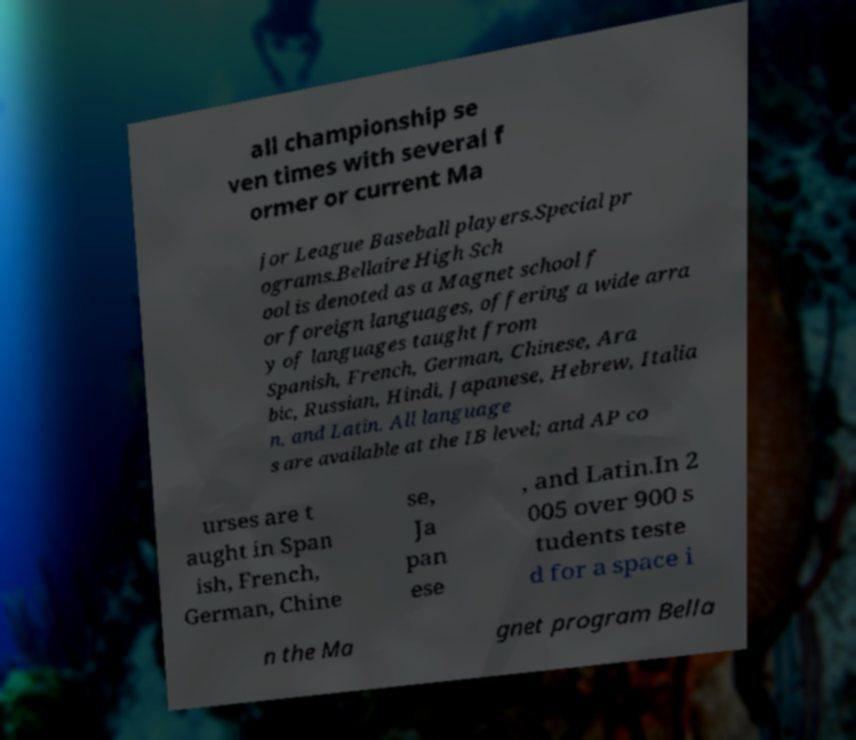Could you assist in decoding the text presented in this image and type it out clearly? all championship se ven times with several f ormer or current Ma jor League Baseball players.Special pr ograms.Bellaire High Sch ool is denoted as a Magnet school f or foreign languages, offering a wide arra y of languages taught from Spanish, French, German, Chinese, Ara bic, Russian, Hindi, Japanese, Hebrew, Italia n, and Latin. All language s are available at the IB level; and AP co urses are t aught in Span ish, French, German, Chine se, Ja pan ese , and Latin.In 2 005 over 900 s tudents teste d for a space i n the Ma gnet program Bella 